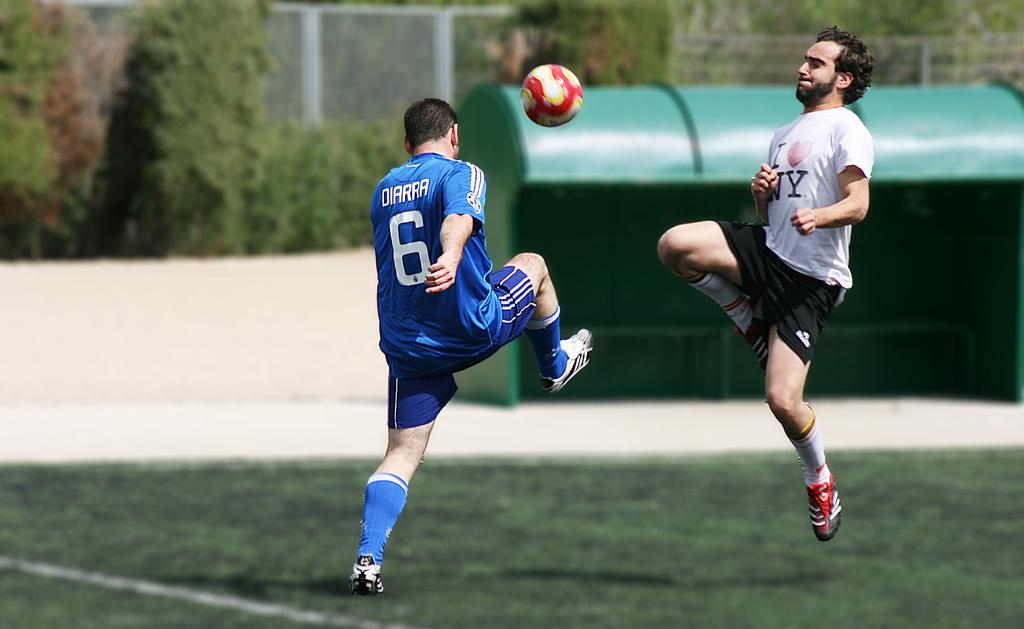How many people are in the image? There are two men in the image. What are the men doing in the image? The men are playing football. What is happening with the ball in the image? There is a ball in the air. What can be seen in the background of the image? There is a shed, trees, and fencing in the background of the image. What type of toad can be seen hopping in the image? There is no toad present in the image; it features two men playing football with a ball in the air. 